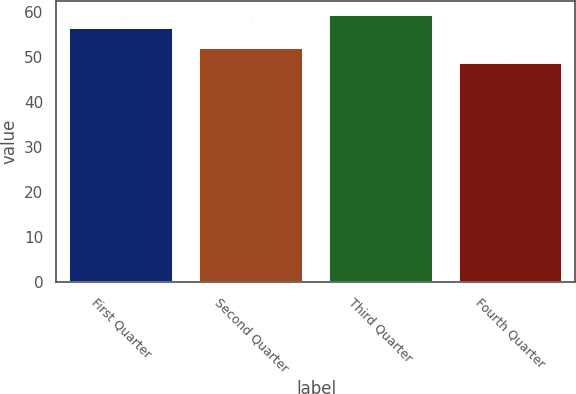Convert chart. <chart><loc_0><loc_0><loc_500><loc_500><bar_chart><fcel>First Quarter<fcel>Second Quarter<fcel>Third Quarter<fcel>Fourth Quarter<nl><fcel>56.49<fcel>52.05<fcel>59.49<fcel>48.78<nl></chart> 